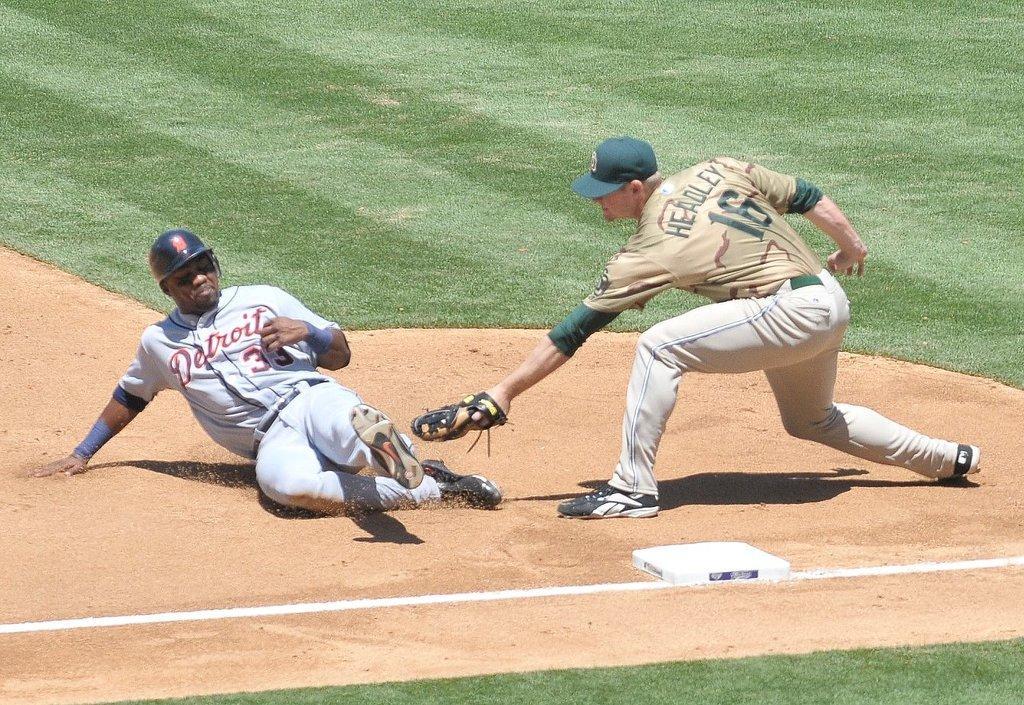How would you summarize this image in a sentence or two? In this image there are two baseball players on a ground. 